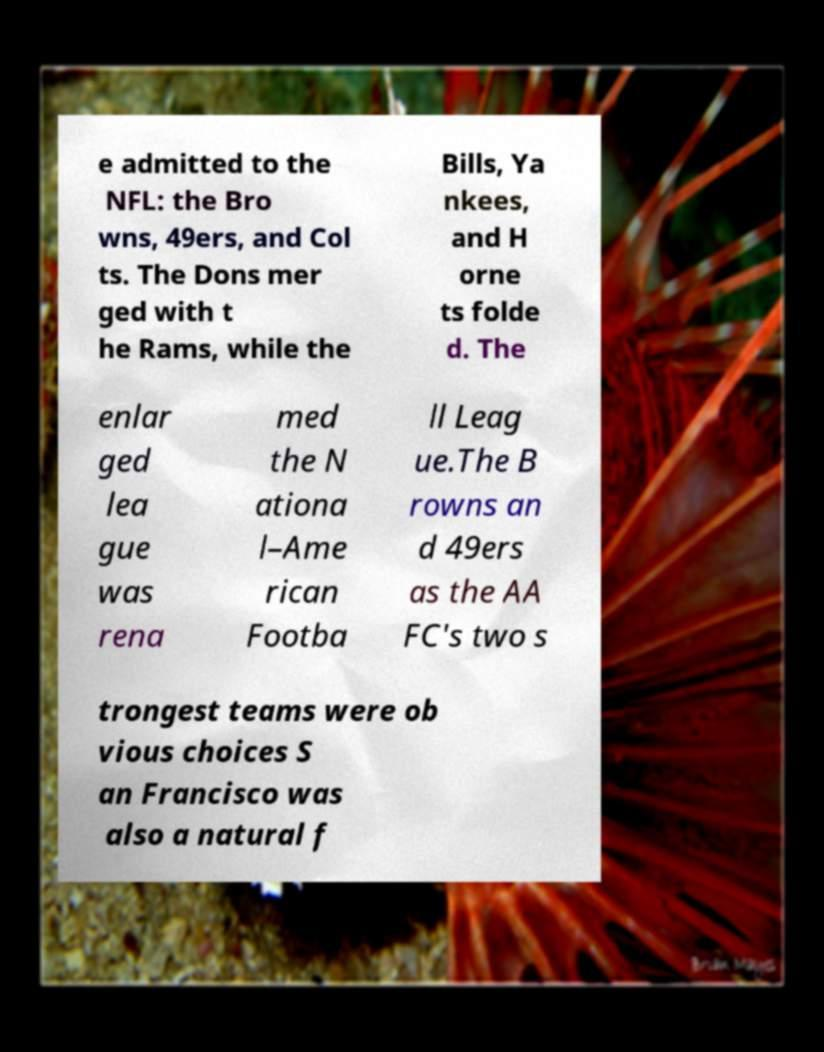Please identify and transcribe the text found in this image. e admitted to the NFL: the Bro wns, 49ers, and Col ts. The Dons mer ged with t he Rams, while the Bills, Ya nkees, and H orne ts folde d. The enlar ged lea gue was rena med the N ationa l–Ame rican Footba ll Leag ue.The B rowns an d 49ers as the AA FC's two s trongest teams were ob vious choices S an Francisco was also a natural f 